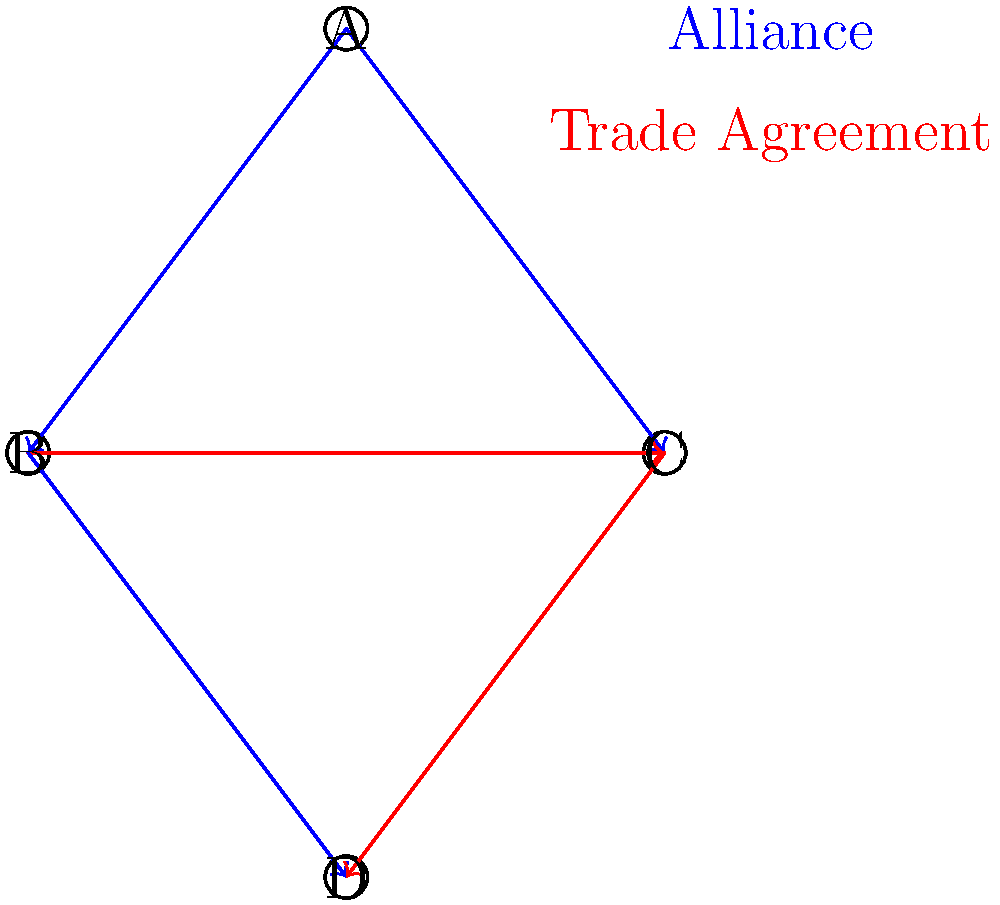Based on the network graph of international alliances and trade agreements, which country has the most strategic position in terms of both military alliances and economic partnerships? To determine the most strategically positioned country, we need to analyze each country's connections:

1. Country A:
   - Has two alliance connections (blue arrows) to B and C
   - No trade agreements
   - Total: 2 connections

2. Country B:
   - Has two alliance connections (blue arrows) to A and D
   - Has one trade agreement (red arrow) with C
   - Total: 3 connections

3. Country C:
   - Has one alliance connection (blue arrow) to A
   - Has two trade agreements (red arrows) with B and D
   - Total: 3 connections

4. Country D:
   - Has one alliance connection (blue arrow) from B
   - Has one trade agreement (red arrow) from C
   - Total: 2 connections

Countries B and C both have the highest number of total connections (3 each). However, B has a more balanced mix of alliances (2) and trade agreements (1), while C has more trade agreements (2) than alliances (1).

In terms of power dynamics, having a balance of military alliances and economic partnerships is generally more advantageous. This allows a country to leverage both security and economic influence.

Therefore, Country B has the most strategic position, as it maintains two military alliances and one trade agreement, giving it a strong presence in both security and economic spheres.
Answer: Country B 